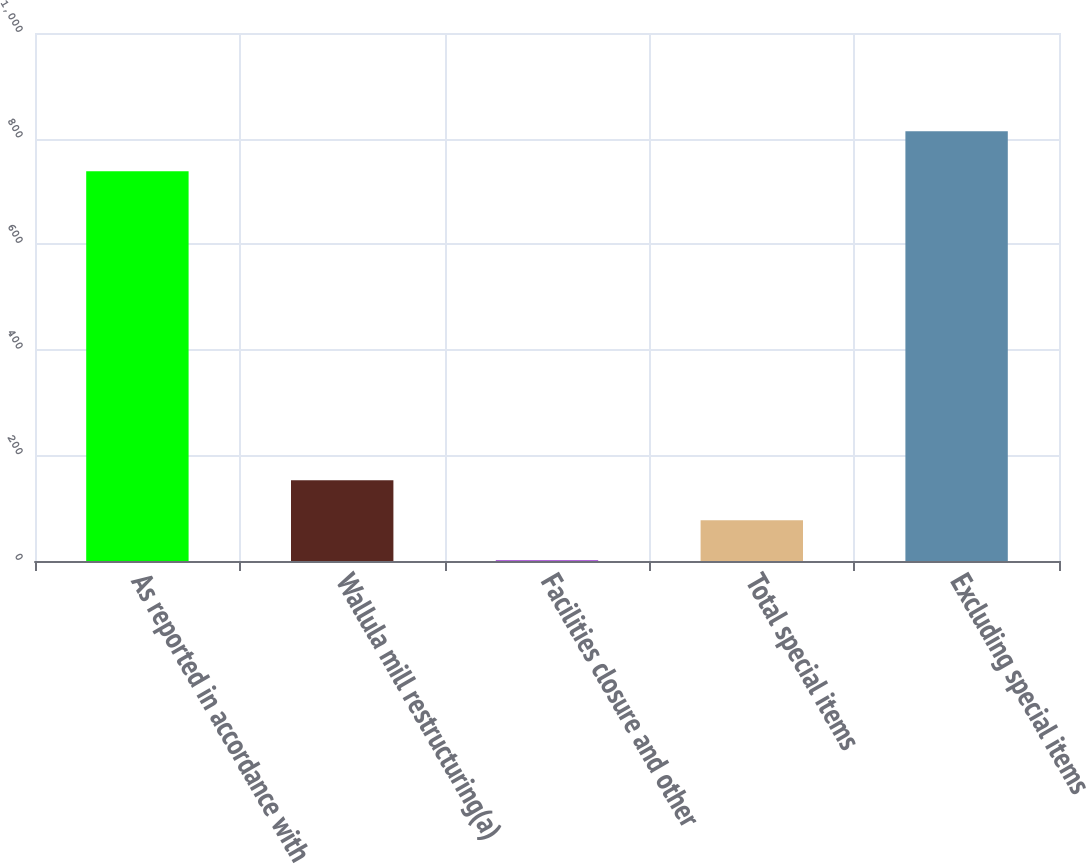Convert chart. <chart><loc_0><loc_0><loc_500><loc_500><bar_chart><fcel>As reported in accordance with<fcel>Wallula mill restructuring(a)<fcel>Facilities closure and other<fcel>Total special items<fcel>Excluding special items<nl><fcel>738<fcel>153.12<fcel>1.3<fcel>77.21<fcel>813.91<nl></chart> 